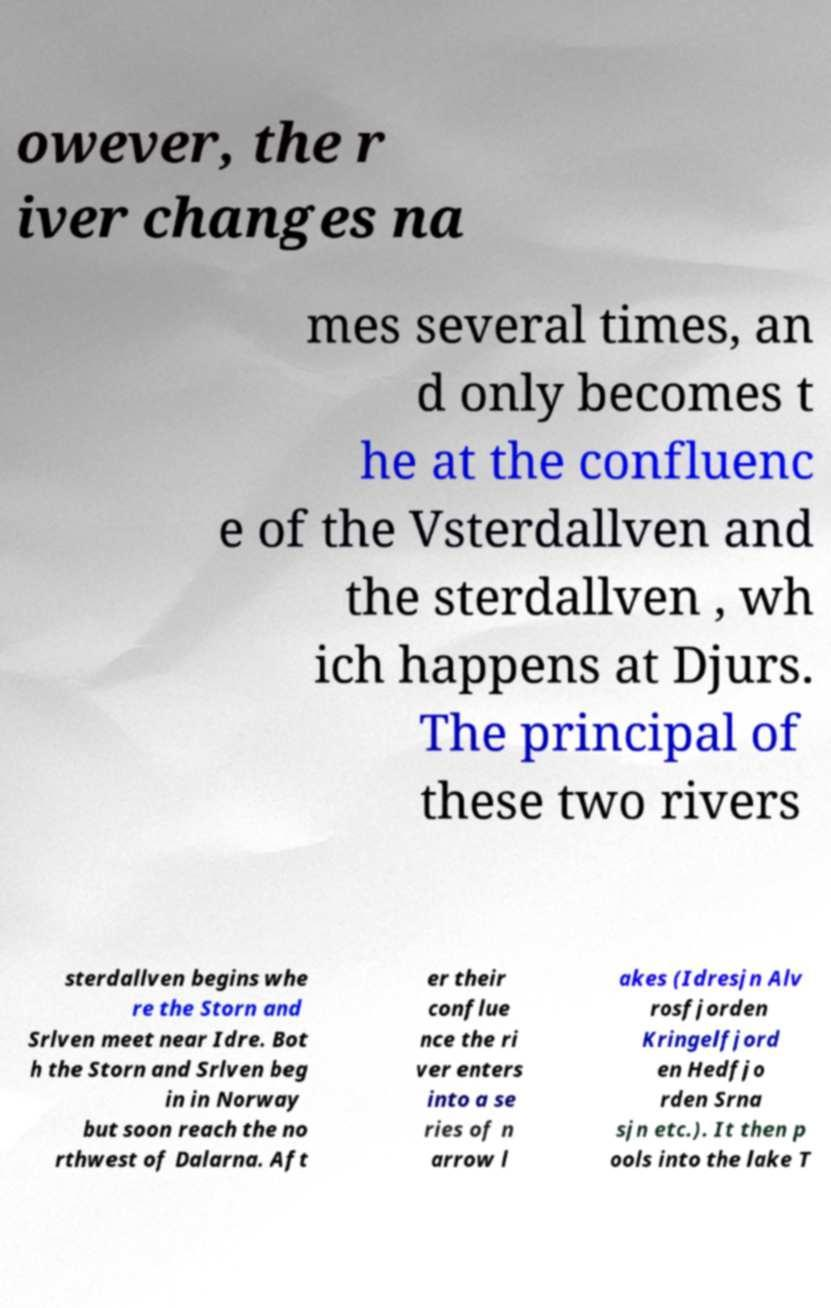Could you assist in decoding the text presented in this image and type it out clearly? owever, the r iver changes na mes several times, an d only becomes t he at the confluenc e of the Vsterdallven and the sterdallven , wh ich happens at Djurs. The principal of these two rivers sterdallven begins whe re the Storn and Srlven meet near Idre. Bot h the Storn and Srlven beg in in Norway but soon reach the no rthwest of Dalarna. Aft er their conflue nce the ri ver enters into a se ries of n arrow l akes (Idresjn Alv rosfjorden Kringelfjord en Hedfjo rden Srna sjn etc.). It then p ools into the lake T 